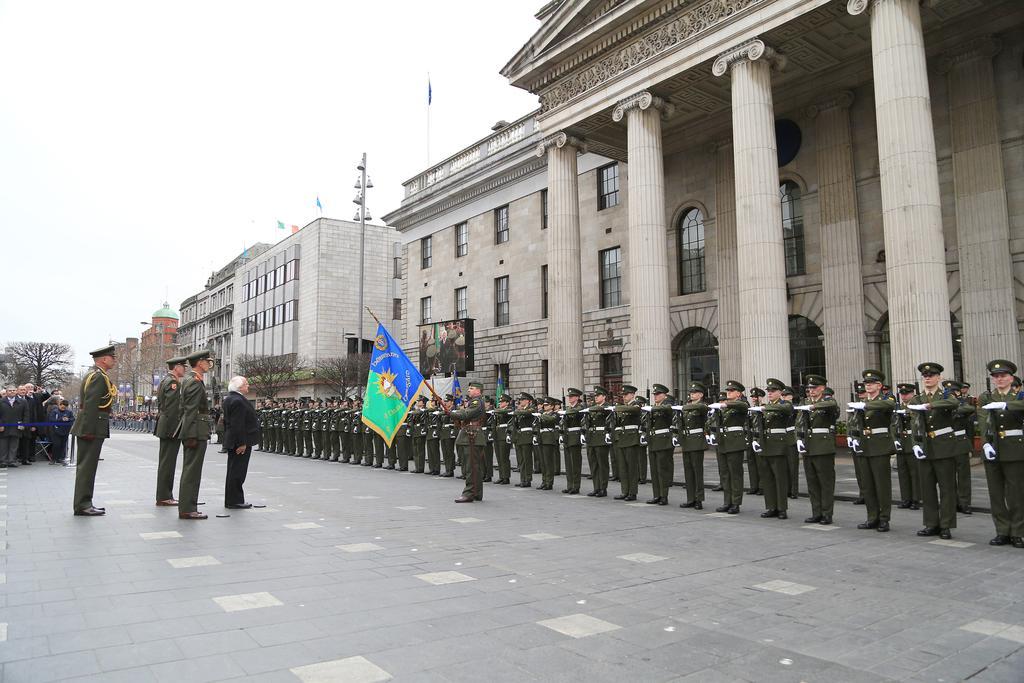How would you summarize this image in a sentence or two? In this image, on the right side, we can see a group of people. On the right side, we can see a building, pillars, glass window, flags. In the middle of the image, we can see a person standing on the floor and holding a flag in his hand. On the left side, we can also see a group of trees, people. In the background, we can see a building, street light. At the top, we can see a sky. 